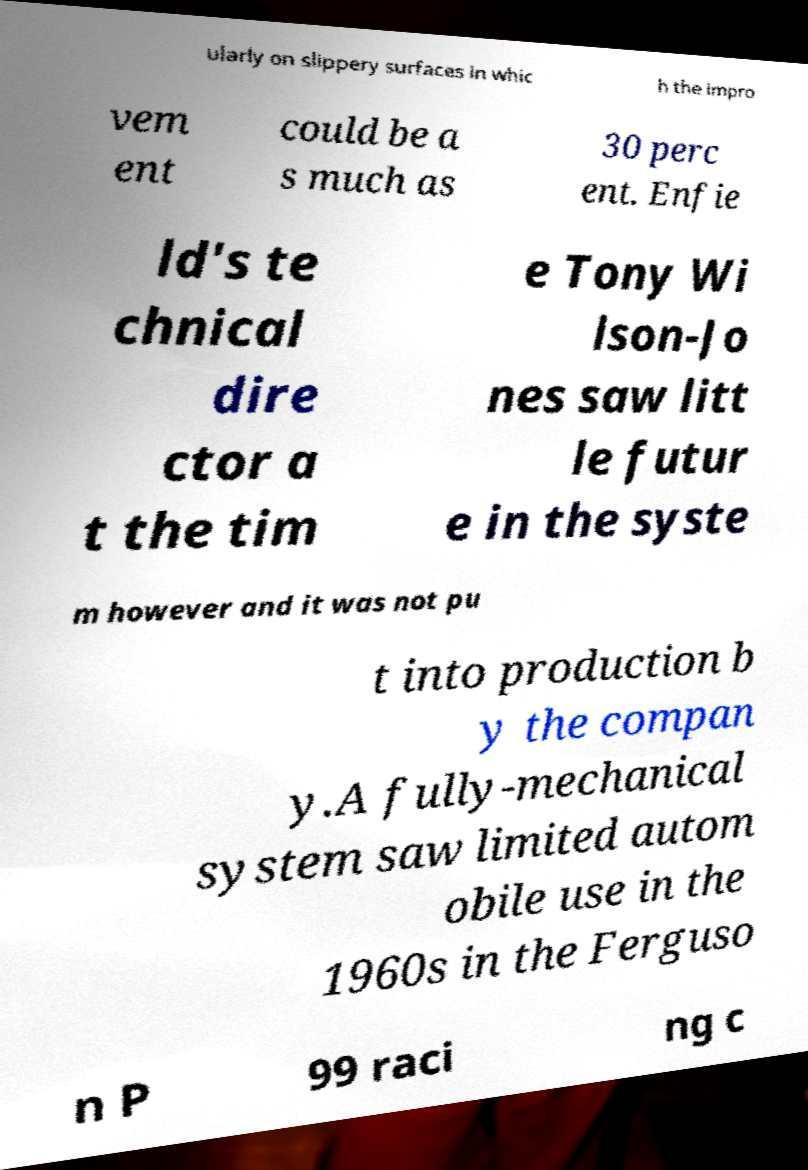Could you assist in decoding the text presented in this image and type it out clearly? ularly on slippery surfaces in whic h the impro vem ent could be a s much as 30 perc ent. Enfie ld's te chnical dire ctor a t the tim e Tony Wi lson-Jo nes saw litt le futur e in the syste m however and it was not pu t into production b y the compan y.A fully-mechanical system saw limited autom obile use in the 1960s in the Ferguso n P 99 raci ng c 